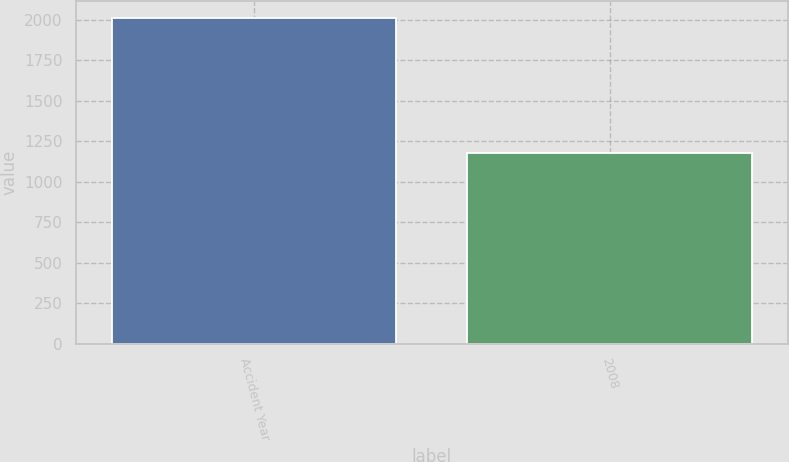Convert chart to OTSL. <chart><loc_0><loc_0><loc_500><loc_500><bar_chart><fcel>Accident Year<fcel>2008<nl><fcel>2014<fcel>1181<nl></chart> 